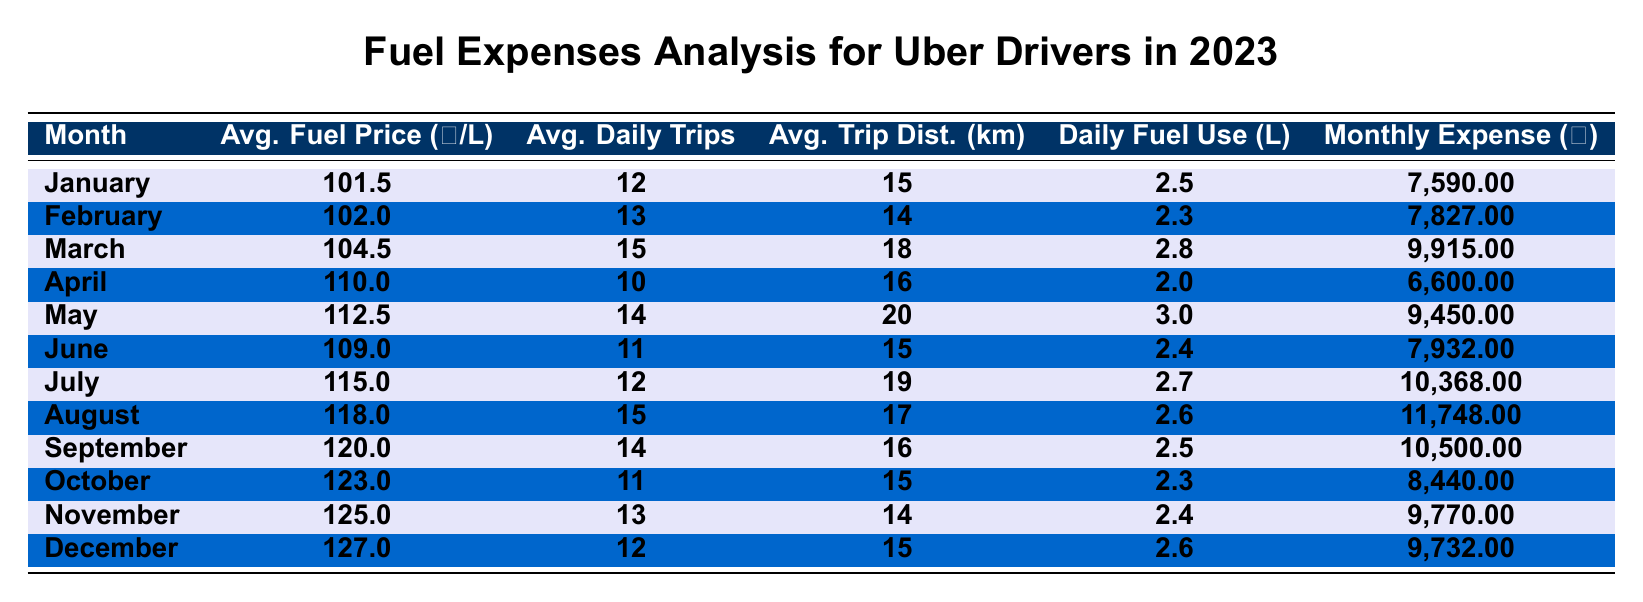What's the average fuel price per litre in December? Referring to the table, the average fuel price per litre in December is listed as 127.0.
Answer: 127.0 What was the monthly fuel expense in March? The table shows that in March, the monthly fuel expense was 9,915.00.
Answer: 9,915.00 How many litres of fuel did an Uber driver use daily on average in July? The table indicates that the daily fuel consumption in July was 2.7 litres.
Answer: 2.7 Which month had the highest average daily trip count? By examining the table, March shows the highest average daily trip count at 15 trips.
Answer: March What is the total monthly fuel expense for the first quarter (January, February, March)? Summing up the monthly expenses gives: 7,590 (Jan) + 7,827 (Feb) + 9,915 (Mar) = 25,332.
Answer: 25,332 Did the average fuel price decrease from June to July? The average fuel price in June was 109.0, and in July it increased to 115.0, indicating a decrease did not occur.
Answer: No What is the monthly fuel expense difference between August and April? The expenses are: August 11,748 and April 6,600. The difference is 11,748 - 6,600 = 5,148.
Answer: 5,148 Which month had the lowest average trip distance? Analyzing the table, February shows the lowest average trip distance at 14 km.
Answer: February What is the average daily fuel consumption across the entire year? To find the average daily fuel consumption, sum the daily consumption for all months (2.5 + 2.3 + 2.8 + 2.0 + 3.0 + 2.4 + 2.7 + 2.6 + 2.5 + 2.3 + 2.4 + 2.6 = 30.0) and divide by 12 (months), which gives 30.0 / 12 = 2.5 litres.
Answer: 2.5 Which month had a monthly fuel expense over 10,000? From the table, only March (9,915), July (10,368), August (11,748), and September (10,500) had expenses over 10,000.
Answer: March, July, August, September 